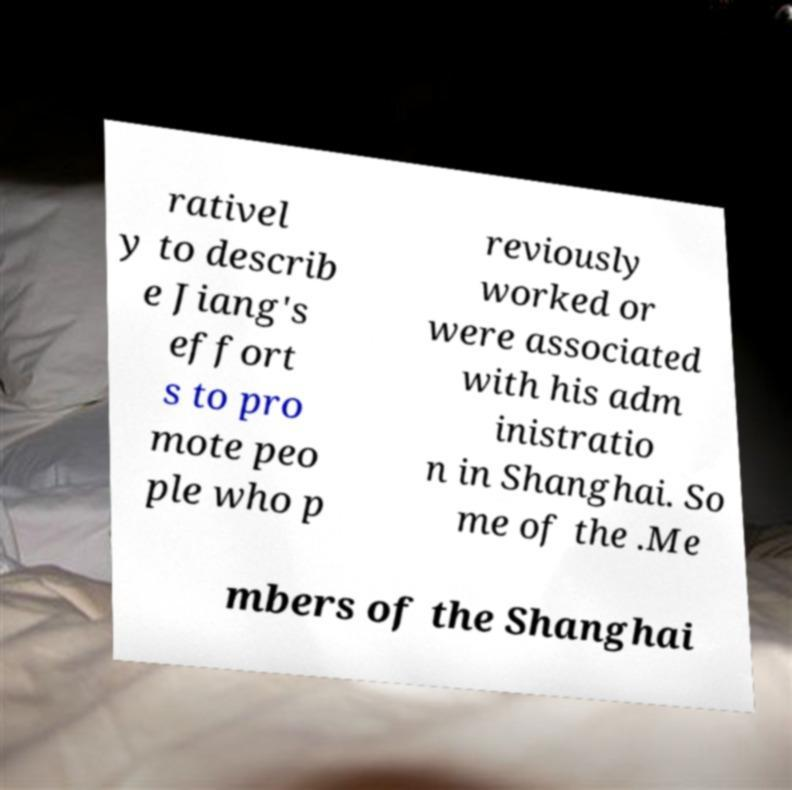What messages or text are displayed in this image? I need them in a readable, typed format. rativel y to describ e Jiang's effort s to pro mote peo ple who p reviously worked or were associated with his adm inistratio n in Shanghai. So me of the .Me mbers of the Shanghai 